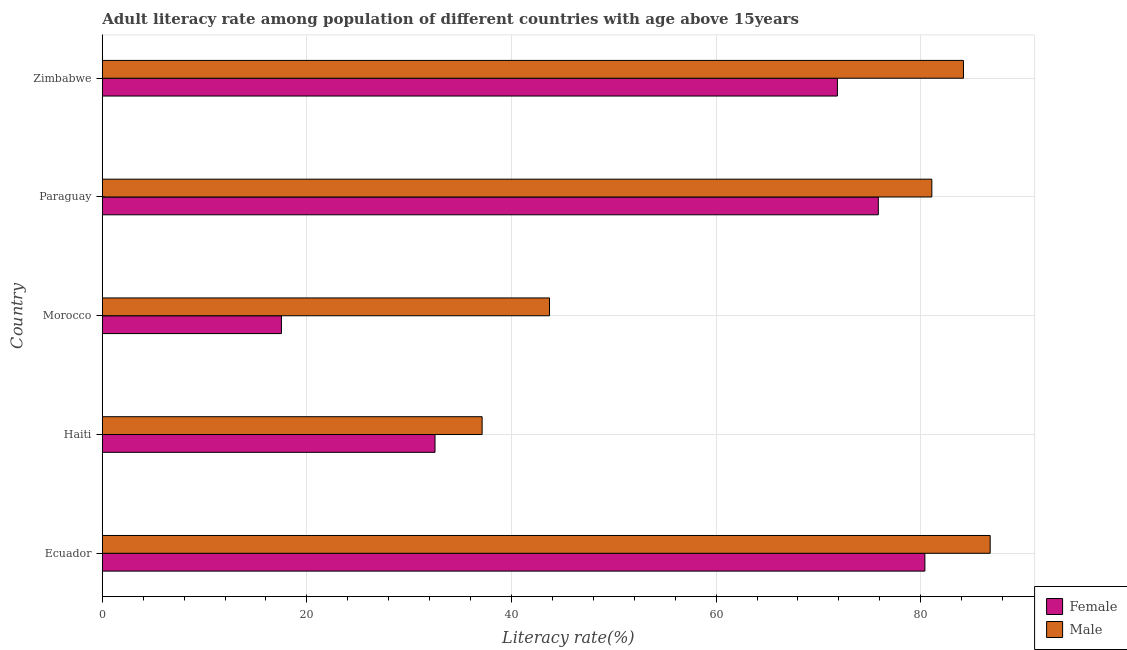How many different coloured bars are there?
Your answer should be compact. 2. Are the number of bars per tick equal to the number of legend labels?
Offer a terse response. Yes. Are the number of bars on each tick of the Y-axis equal?
Offer a very short reply. Yes. How many bars are there on the 5th tick from the bottom?
Offer a very short reply. 2. What is the label of the 1st group of bars from the top?
Give a very brief answer. Zimbabwe. In how many cases, is the number of bars for a given country not equal to the number of legend labels?
Give a very brief answer. 0. What is the female adult literacy rate in Morocco?
Offer a terse response. 17.51. Across all countries, what is the maximum male adult literacy rate?
Offer a very short reply. 86.79. Across all countries, what is the minimum female adult literacy rate?
Your answer should be compact. 17.51. In which country was the female adult literacy rate maximum?
Provide a succinct answer. Ecuador. In which country was the male adult literacy rate minimum?
Your answer should be compact. Haiti. What is the total female adult literacy rate in the graph?
Provide a succinct answer. 278.15. What is the difference between the male adult literacy rate in Ecuador and that in Paraguay?
Your response must be concise. 5.7. What is the difference between the female adult literacy rate in Morocco and the male adult literacy rate in Haiti?
Provide a succinct answer. -19.61. What is the average female adult literacy rate per country?
Ensure brevity in your answer.  55.63. What is the difference between the female adult literacy rate and male adult literacy rate in Ecuador?
Provide a short and direct response. -6.38. What is the ratio of the male adult literacy rate in Morocco to that in Paraguay?
Your answer should be very brief. 0.54. Is the difference between the female adult literacy rate in Haiti and Paraguay greater than the difference between the male adult literacy rate in Haiti and Paraguay?
Your answer should be very brief. Yes. What is the difference between the highest and the second highest female adult literacy rate?
Give a very brief answer. 4.55. What is the difference between the highest and the lowest male adult literacy rate?
Provide a short and direct response. 49.66. Is the sum of the male adult literacy rate in Ecuador and Haiti greater than the maximum female adult literacy rate across all countries?
Keep it short and to the point. Yes. What does the 1st bar from the bottom in Paraguay represents?
Keep it short and to the point. Female. What is the difference between two consecutive major ticks on the X-axis?
Your response must be concise. 20. Are the values on the major ticks of X-axis written in scientific E-notation?
Keep it short and to the point. No. Does the graph contain any zero values?
Offer a very short reply. No. Where does the legend appear in the graph?
Provide a short and direct response. Bottom right. How many legend labels are there?
Ensure brevity in your answer.  2. How are the legend labels stacked?
Make the answer very short. Vertical. What is the title of the graph?
Provide a short and direct response. Adult literacy rate among population of different countries with age above 15years. Does "Sanitation services" appear as one of the legend labels in the graph?
Provide a short and direct response. No. What is the label or title of the X-axis?
Give a very brief answer. Literacy rate(%). What is the Literacy rate(%) in Female in Ecuador?
Provide a short and direct response. 80.41. What is the Literacy rate(%) in Male in Ecuador?
Provide a succinct answer. 86.79. What is the Literacy rate(%) of Female in Haiti?
Make the answer very short. 32.52. What is the Literacy rate(%) in Male in Haiti?
Make the answer very short. 37.13. What is the Literacy rate(%) in Female in Morocco?
Give a very brief answer. 17.51. What is the Literacy rate(%) of Male in Morocco?
Your answer should be compact. 43.71. What is the Literacy rate(%) of Female in Paraguay?
Ensure brevity in your answer.  75.85. What is the Literacy rate(%) of Male in Paraguay?
Make the answer very short. 81.08. What is the Literacy rate(%) in Female in Zimbabwe?
Provide a short and direct response. 71.85. What is the Literacy rate(%) in Male in Zimbabwe?
Provide a succinct answer. 84.17. Across all countries, what is the maximum Literacy rate(%) in Female?
Your response must be concise. 80.41. Across all countries, what is the maximum Literacy rate(%) of Male?
Offer a terse response. 86.79. Across all countries, what is the minimum Literacy rate(%) in Female?
Ensure brevity in your answer.  17.51. Across all countries, what is the minimum Literacy rate(%) of Male?
Give a very brief answer. 37.13. What is the total Literacy rate(%) of Female in the graph?
Give a very brief answer. 278.15. What is the total Literacy rate(%) in Male in the graph?
Offer a terse response. 332.89. What is the difference between the Literacy rate(%) in Female in Ecuador and that in Haiti?
Your response must be concise. 47.88. What is the difference between the Literacy rate(%) of Male in Ecuador and that in Haiti?
Ensure brevity in your answer.  49.66. What is the difference between the Literacy rate(%) in Female in Ecuador and that in Morocco?
Your response must be concise. 62.89. What is the difference between the Literacy rate(%) in Male in Ecuador and that in Morocco?
Provide a short and direct response. 43.07. What is the difference between the Literacy rate(%) in Female in Ecuador and that in Paraguay?
Offer a terse response. 4.55. What is the difference between the Literacy rate(%) of Male in Ecuador and that in Paraguay?
Give a very brief answer. 5.7. What is the difference between the Literacy rate(%) in Female in Ecuador and that in Zimbabwe?
Ensure brevity in your answer.  8.55. What is the difference between the Literacy rate(%) in Male in Ecuador and that in Zimbabwe?
Provide a short and direct response. 2.61. What is the difference between the Literacy rate(%) in Female in Haiti and that in Morocco?
Provide a short and direct response. 15.01. What is the difference between the Literacy rate(%) of Male in Haiti and that in Morocco?
Provide a short and direct response. -6.58. What is the difference between the Literacy rate(%) of Female in Haiti and that in Paraguay?
Keep it short and to the point. -43.33. What is the difference between the Literacy rate(%) of Male in Haiti and that in Paraguay?
Give a very brief answer. -43.95. What is the difference between the Literacy rate(%) of Female in Haiti and that in Zimbabwe?
Keep it short and to the point. -39.33. What is the difference between the Literacy rate(%) in Male in Haiti and that in Zimbabwe?
Your answer should be compact. -47.04. What is the difference between the Literacy rate(%) in Female in Morocco and that in Paraguay?
Provide a succinct answer. -58.34. What is the difference between the Literacy rate(%) in Male in Morocco and that in Paraguay?
Your answer should be very brief. -37.37. What is the difference between the Literacy rate(%) in Female in Morocco and that in Zimbabwe?
Give a very brief answer. -54.34. What is the difference between the Literacy rate(%) in Male in Morocco and that in Zimbabwe?
Make the answer very short. -40.46. What is the difference between the Literacy rate(%) of Female in Paraguay and that in Zimbabwe?
Offer a terse response. 4. What is the difference between the Literacy rate(%) in Male in Paraguay and that in Zimbabwe?
Make the answer very short. -3.09. What is the difference between the Literacy rate(%) in Female in Ecuador and the Literacy rate(%) in Male in Haiti?
Keep it short and to the point. 43.28. What is the difference between the Literacy rate(%) of Female in Ecuador and the Literacy rate(%) of Male in Morocco?
Your answer should be very brief. 36.69. What is the difference between the Literacy rate(%) of Female in Ecuador and the Literacy rate(%) of Male in Paraguay?
Ensure brevity in your answer.  -0.68. What is the difference between the Literacy rate(%) in Female in Ecuador and the Literacy rate(%) in Male in Zimbabwe?
Keep it short and to the point. -3.77. What is the difference between the Literacy rate(%) of Female in Haiti and the Literacy rate(%) of Male in Morocco?
Keep it short and to the point. -11.19. What is the difference between the Literacy rate(%) in Female in Haiti and the Literacy rate(%) in Male in Paraguay?
Your answer should be compact. -48.56. What is the difference between the Literacy rate(%) of Female in Haiti and the Literacy rate(%) of Male in Zimbabwe?
Your answer should be very brief. -51.65. What is the difference between the Literacy rate(%) of Female in Morocco and the Literacy rate(%) of Male in Paraguay?
Make the answer very short. -63.57. What is the difference between the Literacy rate(%) of Female in Morocco and the Literacy rate(%) of Male in Zimbabwe?
Provide a short and direct response. -66.66. What is the difference between the Literacy rate(%) in Female in Paraguay and the Literacy rate(%) in Male in Zimbabwe?
Ensure brevity in your answer.  -8.32. What is the average Literacy rate(%) in Female per country?
Provide a short and direct response. 55.63. What is the average Literacy rate(%) in Male per country?
Make the answer very short. 66.58. What is the difference between the Literacy rate(%) of Female and Literacy rate(%) of Male in Ecuador?
Offer a terse response. -6.38. What is the difference between the Literacy rate(%) of Female and Literacy rate(%) of Male in Haiti?
Ensure brevity in your answer.  -4.6. What is the difference between the Literacy rate(%) in Female and Literacy rate(%) in Male in Morocco?
Your answer should be very brief. -26.2. What is the difference between the Literacy rate(%) in Female and Literacy rate(%) in Male in Paraguay?
Your answer should be compact. -5.23. What is the difference between the Literacy rate(%) of Female and Literacy rate(%) of Male in Zimbabwe?
Offer a very short reply. -12.32. What is the ratio of the Literacy rate(%) in Female in Ecuador to that in Haiti?
Keep it short and to the point. 2.47. What is the ratio of the Literacy rate(%) in Male in Ecuador to that in Haiti?
Your answer should be very brief. 2.34. What is the ratio of the Literacy rate(%) in Female in Ecuador to that in Morocco?
Ensure brevity in your answer.  4.59. What is the ratio of the Literacy rate(%) of Male in Ecuador to that in Morocco?
Keep it short and to the point. 1.99. What is the ratio of the Literacy rate(%) of Female in Ecuador to that in Paraguay?
Keep it short and to the point. 1.06. What is the ratio of the Literacy rate(%) in Male in Ecuador to that in Paraguay?
Provide a short and direct response. 1.07. What is the ratio of the Literacy rate(%) of Female in Ecuador to that in Zimbabwe?
Give a very brief answer. 1.12. What is the ratio of the Literacy rate(%) in Male in Ecuador to that in Zimbabwe?
Ensure brevity in your answer.  1.03. What is the ratio of the Literacy rate(%) in Female in Haiti to that in Morocco?
Give a very brief answer. 1.86. What is the ratio of the Literacy rate(%) in Male in Haiti to that in Morocco?
Give a very brief answer. 0.85. What is the ratio of the Literacy rate(%) of Female in Haiti to that in Paraguay?
Provide a succinct answer. 0.43. What is the ratio of the Literacy rate(%) of Male in Haiti to that in Paraguay?
Make the answer very short. 0.46. What is the ratio of the Literacy rate(%) of Female in Haiti to that in Zimbabwe?
Keep it short and to the point. 0.45. What is the ratio of the Literacy rate(%) of Male in Haiti to that in Zimbabwe?
Your answer should be compact. 0.44. What is the ratio of the Literacy rate(%) in Female in Morocco to that in Paraguay?
Give a very brief answer. 0.23. What is the ratio of the Literacy rate(%) of Male in Morocco to that in Paraguay?
Your response must be concise. 0.54. What is the ratio of the Literacy rate(%) in Female in Morocco to that in Zimbabwe?
Your answer should be very brief. 0.24. What is the ratio of the Literacy rate(%) in Male in Morocco to that in Zimbabwe?
Your response must be concise. 0.52. What is the ratio of the Literacy rate(%) of Female in Paraguay to that in Zimbabwe?
Your response must be concise. 1.06. What is the ratio of the Literacy rate(%) in Male in Paraguay to that in Zimbabwe?
Make the answer very short. 0.96. What is the difference between the highest and the second highest Literacy rate(%) in Female?
Your response must be concise. 4.55. What is the difference between the highest and the second highest Literacy rate(%) of Male?
Give a very brief answer. 2.61. What is the difference between the highest and the lowest Literacy rate(%) of Female?
Make the answer very short. 62.89. What is the difference between the highest and the lowest Literacy rate(%) of Male?
Provide a succinct answer. 49.66. 